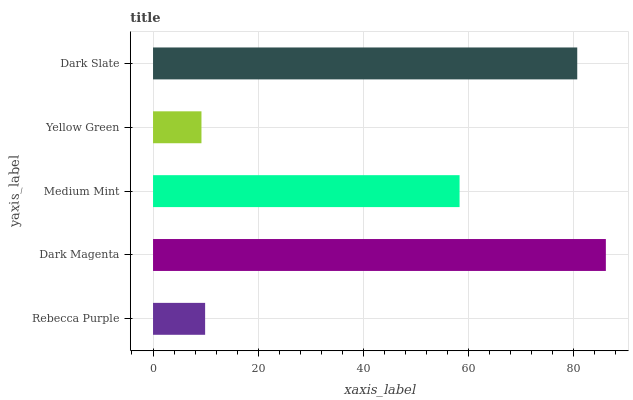Is Yellow Green the minimum?
Answer yes or no. Yes. Is Dark Magenta the maximum?
Answer yes or no. Yes. Is Medium Mint the minimum?
Answer yes or no. No. Is Medium Mint the maximum?
Answer yes or no. No. Is Dark Magenta greater than Medium Mint?
Answer yes or no. Yes. Is Medium Mint less than Dark Magenta?
Answer yes or no. Yes. Is Medium Mint greater than Dark Magenta?
Answer yes or no. No. Is Dark Magenta less than Medium Mint?
Answer yes or no. No. Is Medium Mint the high median?
Answer yes or no. Yes. Is Medium Mint the low median?
Answer yes or no. Yes. Is Rebecca Purple the high median?
Answer yes or no. No. Is Dark Magenta the low median?
Answer yes or no. No. 